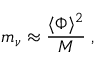<formula> <loc_0><loc_0><loc_500><loc_500>m _ { \nu } \approx { \frac { \langle \Phi \rangle ^ { 2 } } { M } } \, ,</formula> 